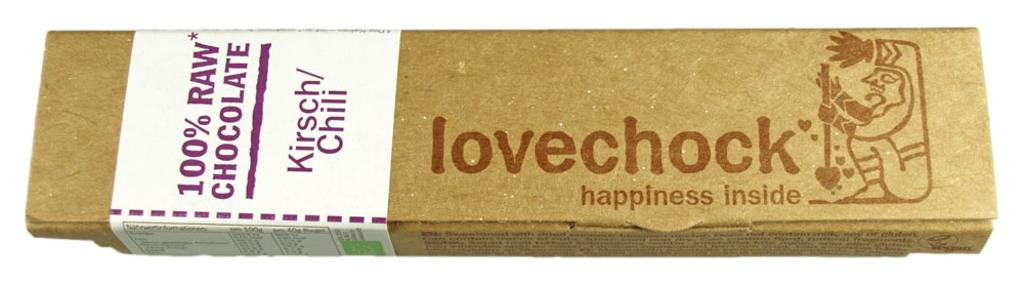Provide a one-sentence caption for the provided image. The lovechohck bar is made with 100% real chocolate and you can find happiness inside each one. 